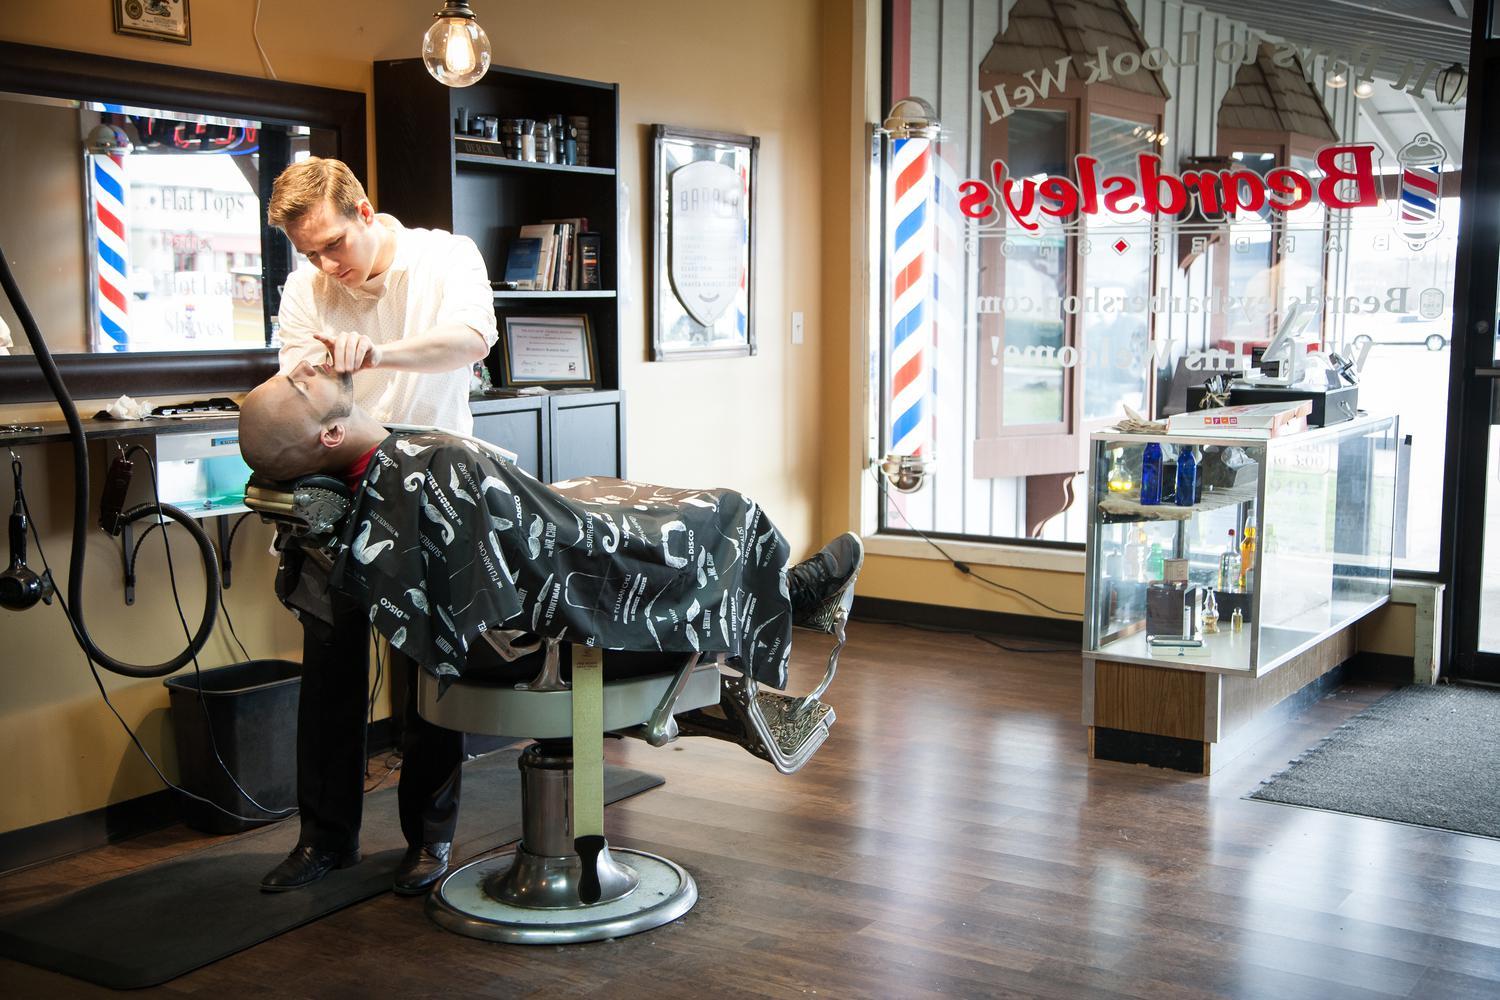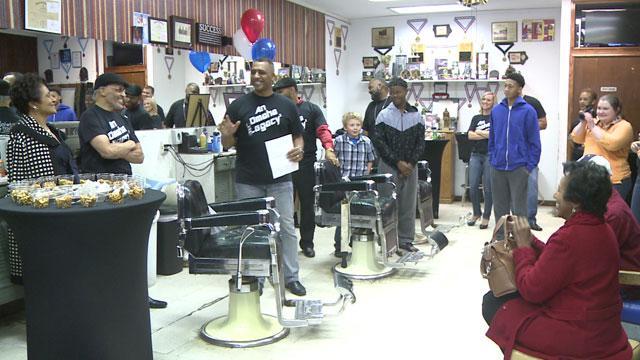The first image is the image on the left, the second image is the image on the right. Given the left and right images, does the statement "There are at least four people in the image on the right." hold true? Answer yes or no. Yes. 